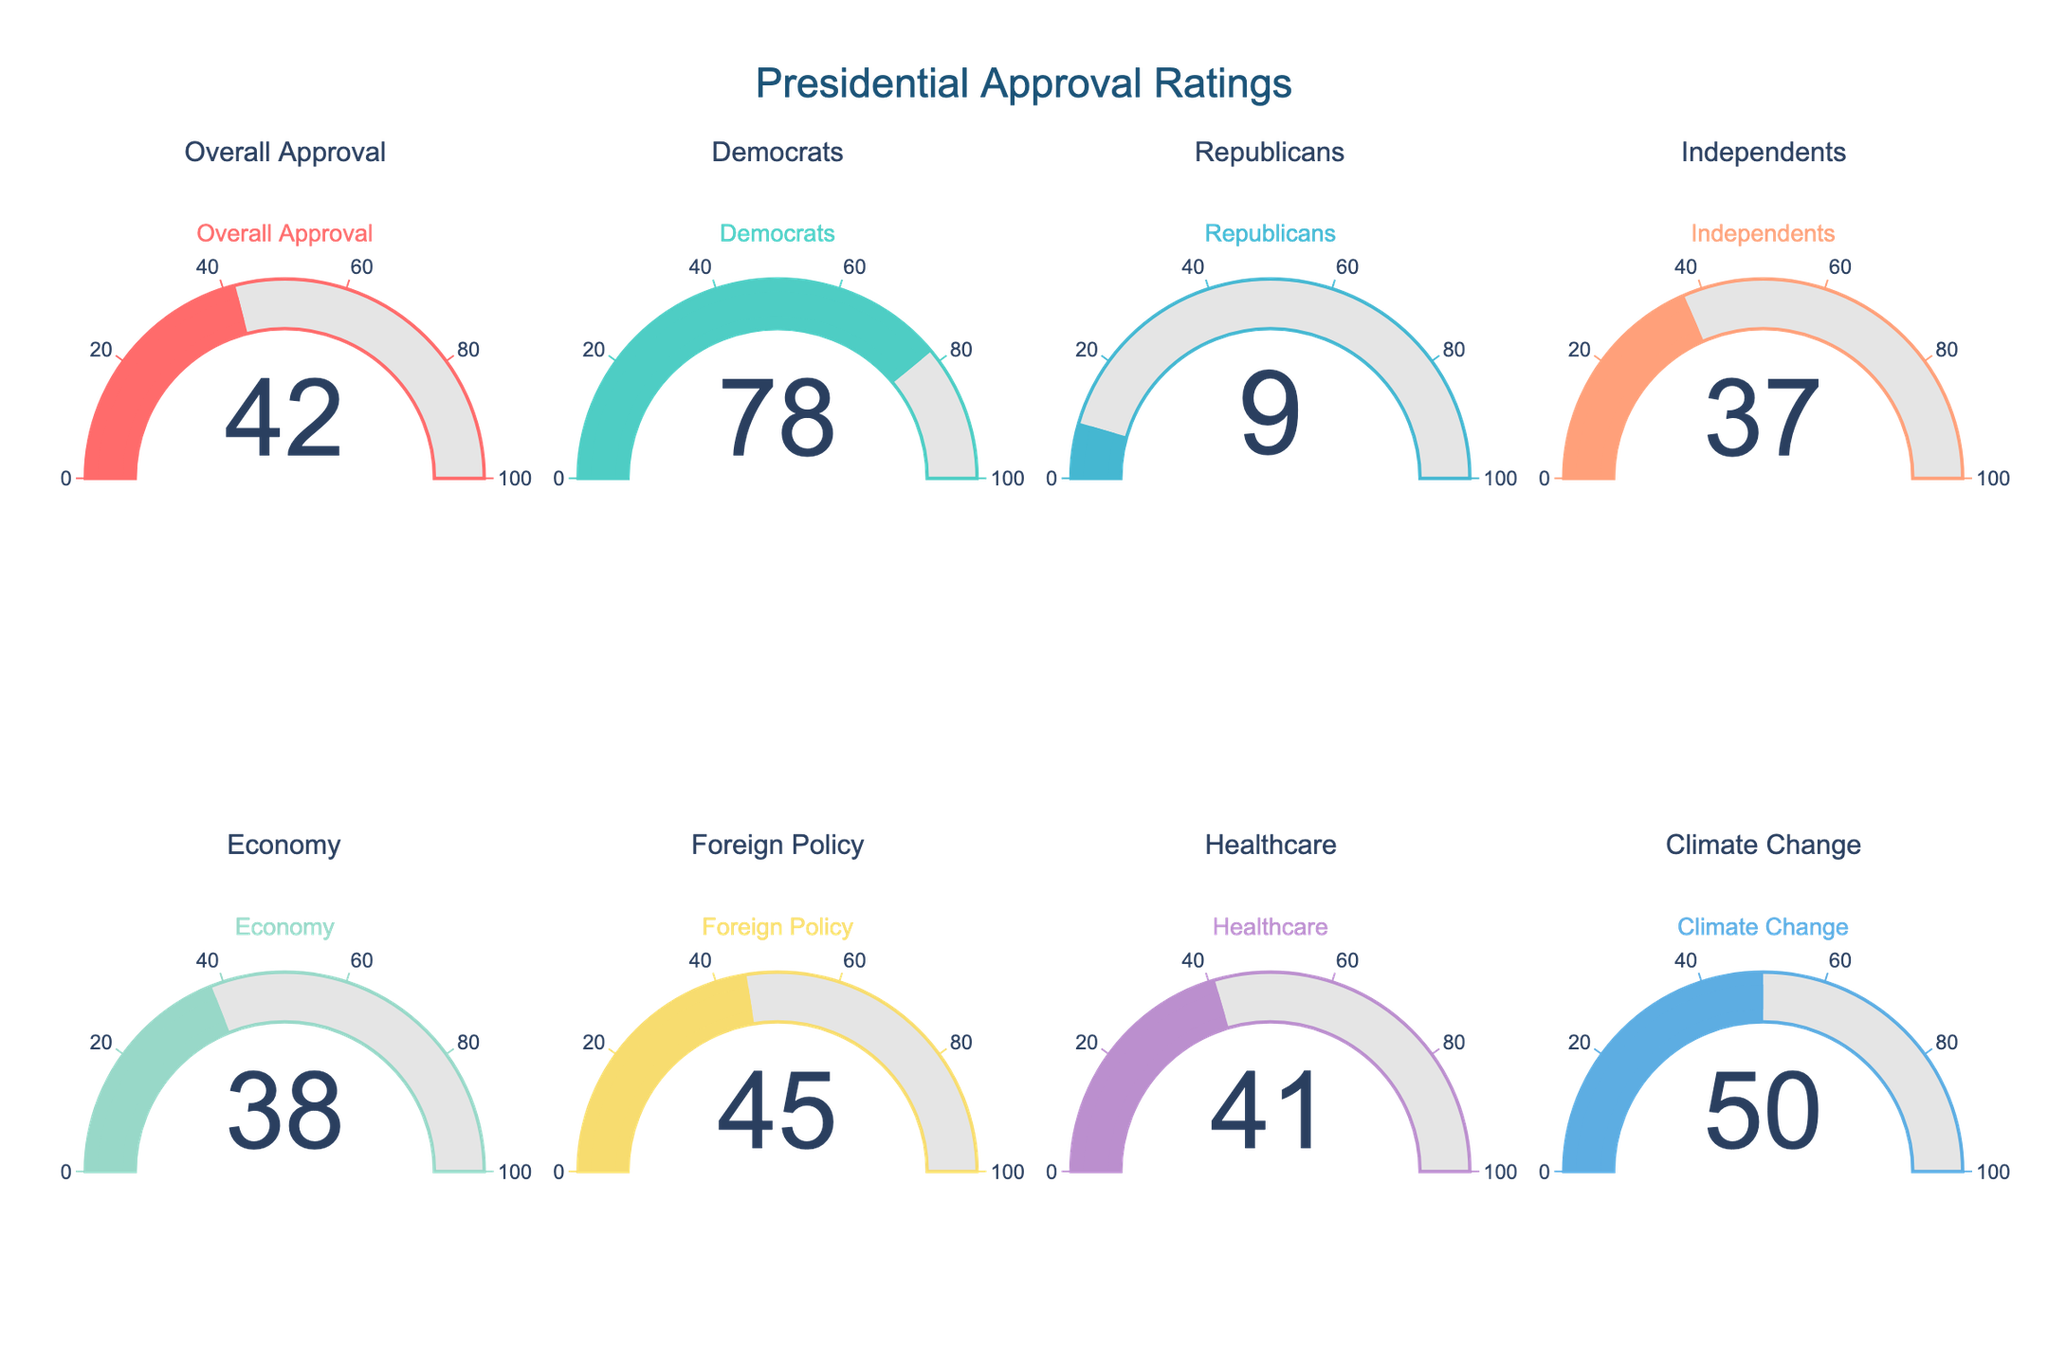what is the overall approval rating of the current president? To determine the overall approval rating, look at the gauge labeled "Overall Approval." The number displayed in the center gives this rating.
Answer: 42 Which political group shows the highest approval rating for the current president? Examine the gauges for the political groups (Democrats, Republicans, Independents). Compare the values shown, and identify the highest one. The Democrats have the highest approval rating.
Answer: Democrats What is the average approval rating for the three political groups: Democrats, Republicans, and Independents? Add the approval ratings for Democrats (78), Republicans (9), and Independents (37). Then, divide this sum by 3 to find the average. (78 + 9 + 37) / 3 = 41.33
Answer: 41.33 Is the president's approval rating on the economy higher than the healthcare rating? Compare the values on the gauges labeled 'Economy' and 'Healthcare.' The economy rating is 38 and healthcare rating is 41.
Answer: No What is the difference between the president's approval rating on foreign policy and climate change? Subtract the approval rating for foreign policy (45) from that of climate change (50). 50 - 45 = 5
Answer: 5 Which policy area has the highest approval rating? Compare the values displayed on the gauges for the different policy areas listed: Economy, Foreign Policy, Healthcare, and Climate Change. The highest value is for Climate Change.
Answer: Climate Change Which approval rating is the lowest among all the categories displayed? Look at all the values on the gauges and identify the smallest one. The lowest approval rating is for Republicans.
Answer: 9 Are any of the policy approval ratings higher than the overall approval rating? Compare the values for the policy areas (Economy, Foreign Policy, Healthcare, and Climate Change) with the overall approval rating (42). Climate Change (50) and Foreign Policy (45) are higher than overall.
Answer: Yes What is the median approval rating across all categories? List the approval ratings: 42, 78, 9, 37, 38, 45, 41, 50. Order them: 9, 37, 38, 41, 42, 45, 50, 78. Find the median, which is the middle value. With 8 values, the median is the average of the 4th and 5th values: (41 + 42) / 2 = 41.5
Answer: 41.5 